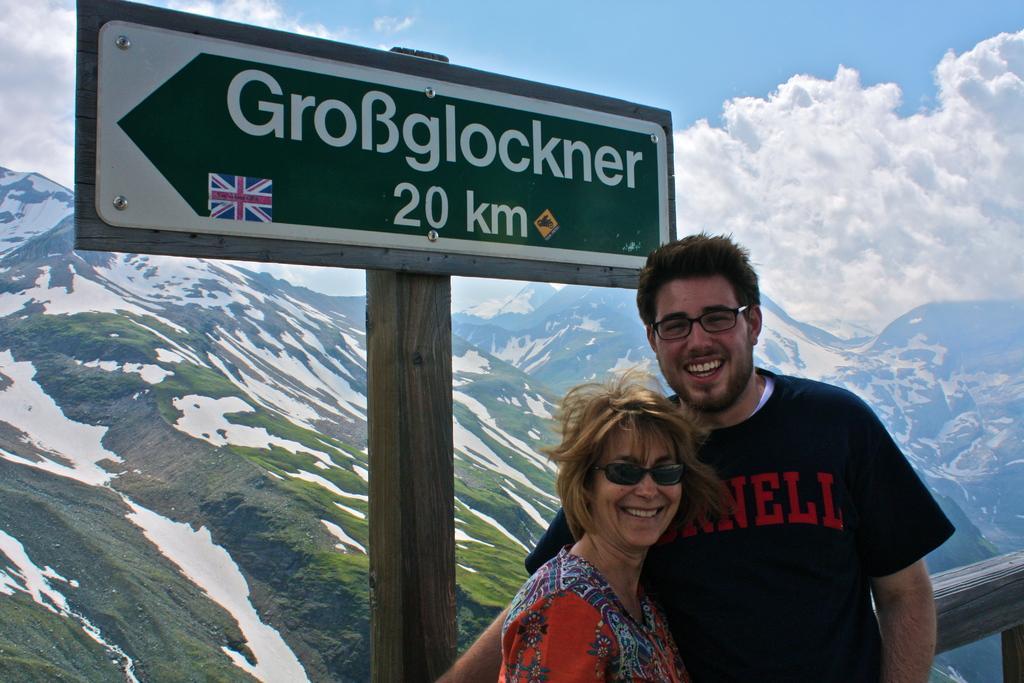How would you summarize this image in a sentence or two? In the image there are two people in the foreground, behind them there is a wooden pole and there is a board attached to the wooden pole with some name and direction, in the background there are mountains. 